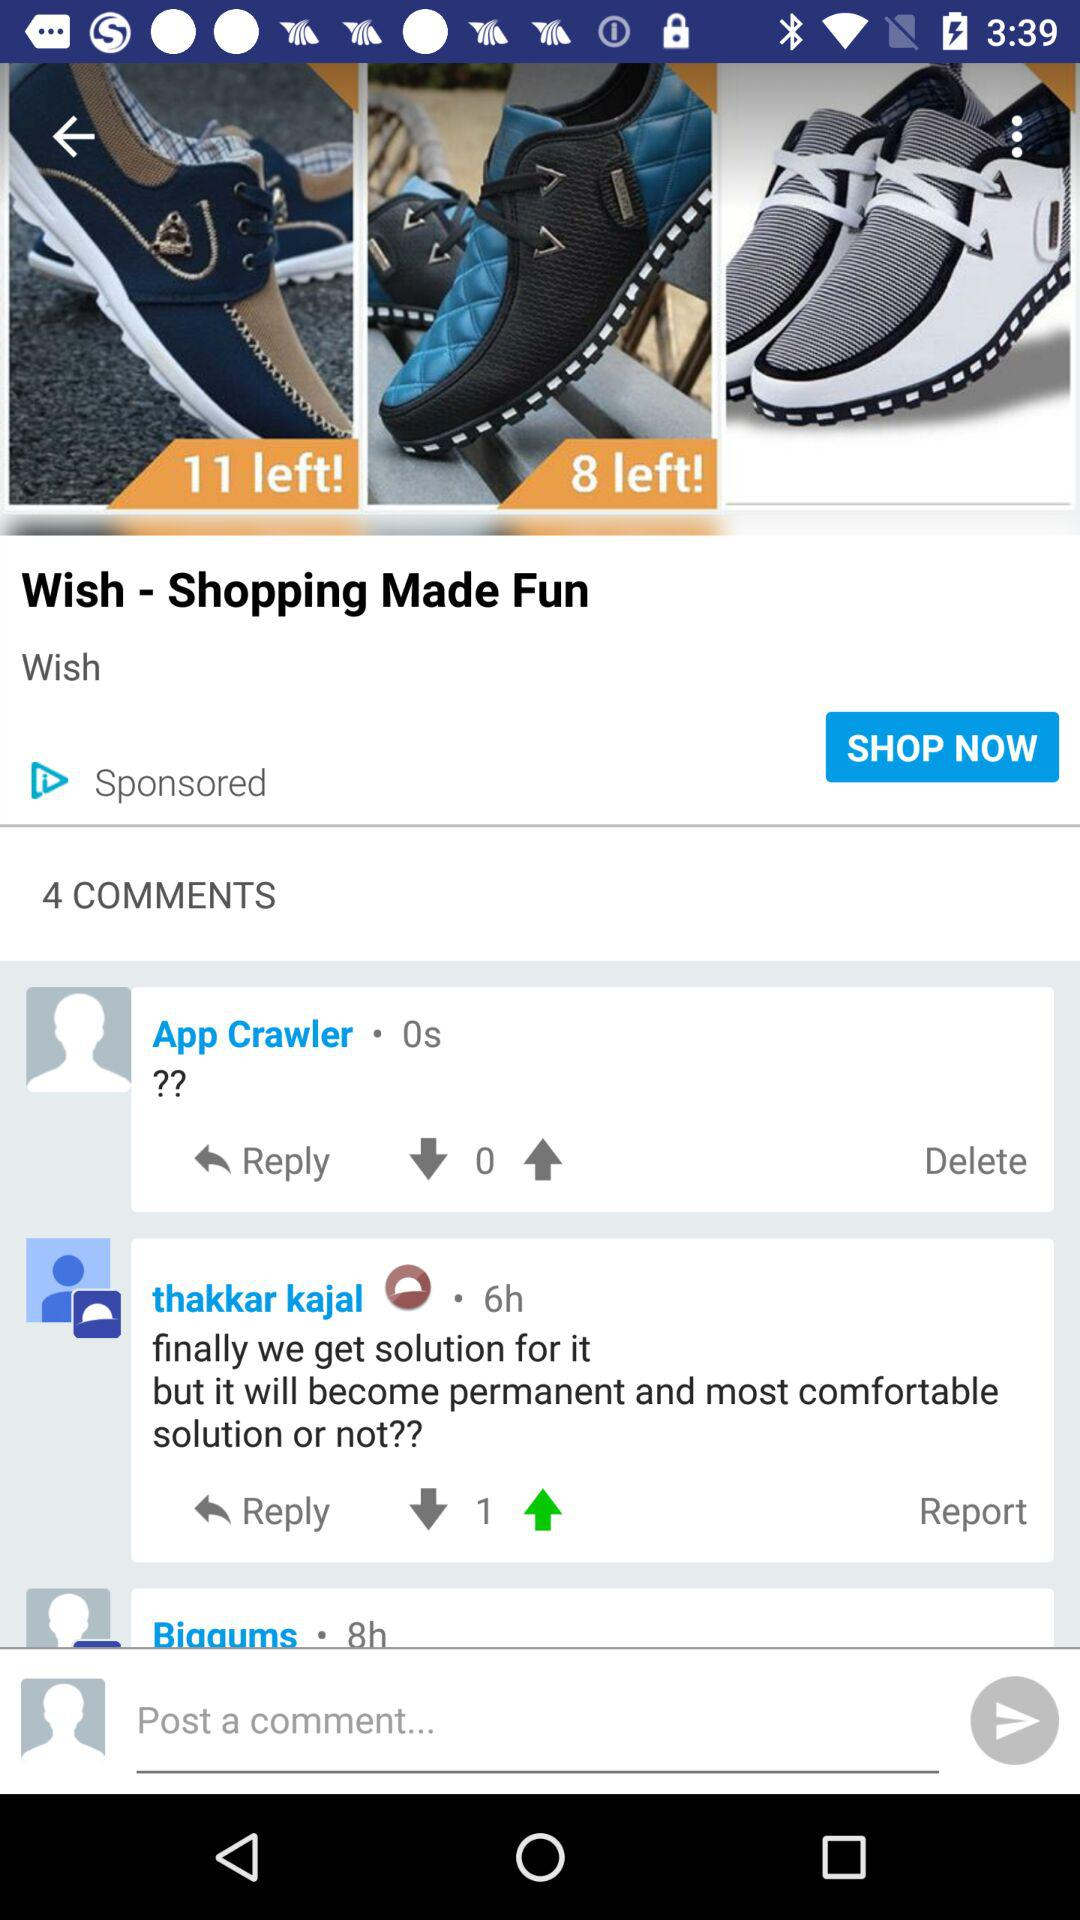Which is the website?
When the provided information is insufficient, respond with <no answer>. <no answer> 